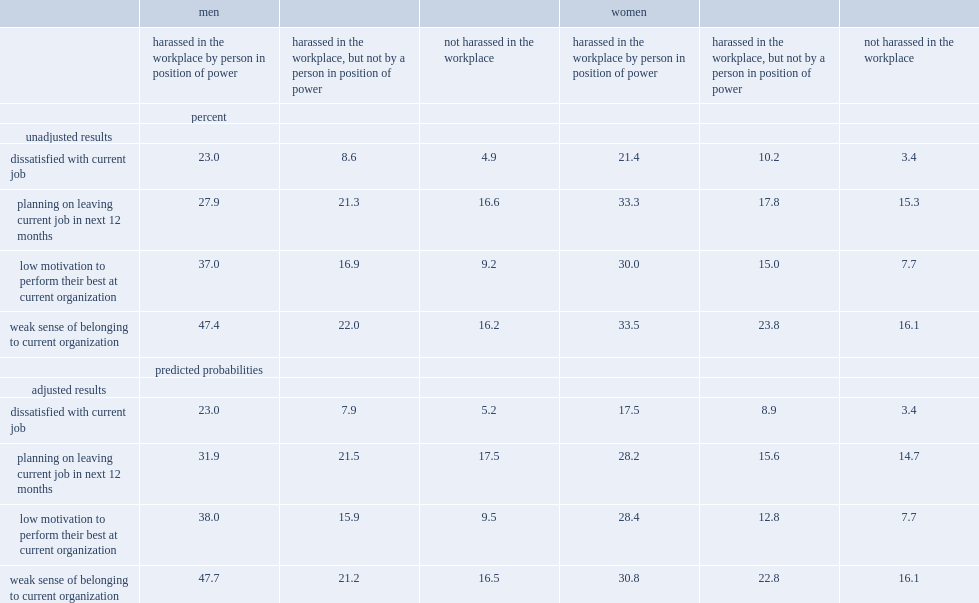Among men who were harassed by a manager or supervisor and those who were harassed by someone other than a person in a position of power,what were the percentages of those reported low levels of job satisfaction respectively? 23.0 8.6. What was the percentage of men who did not report workplace harassment had low levels of job satisfaction? 4.9. Who were more likely to be dissatisfied with their job,women who were harassed by a person in position of power or those who had not been harassed? Harassed in the workplace by person in position of power. What were the percentages of women and men who said they had not been harassed at work in the past year had a weak sense of belonging to their current organization respectively? 16.2 16.1. 